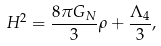<formula> <loc_0><loc_0><loc_500><loc_500>H ^ { 2 } = \frac { 8 \pi G _ { N } } { 3 } \rho + \frac { \Lambda _ { 4 } } { 3 } ,</formula> 